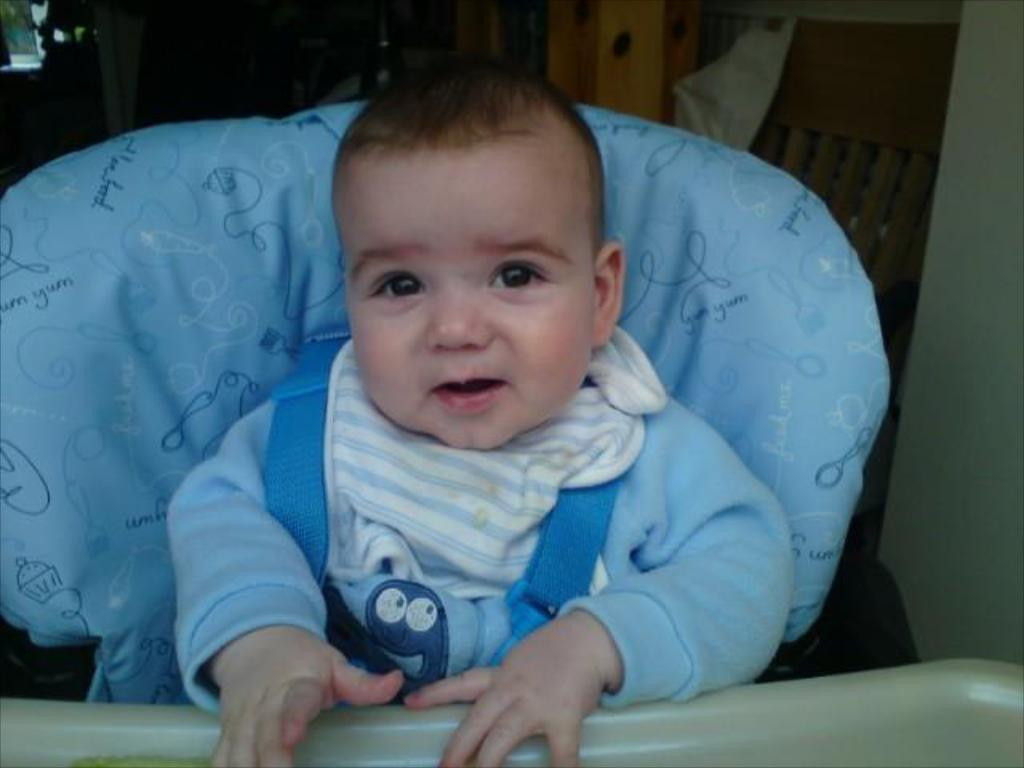What is the main subject of the image? The main subject of the image is a kid. What is the kid doing in the image? The kid is standing on a walker. What can be seen in the background of the image? There is a chair and a wall in the background of the image. How many boats are visible in the image? There are no boats present in the image. Is there a beggar asking for money in the image? There is no beggar present in the image. 